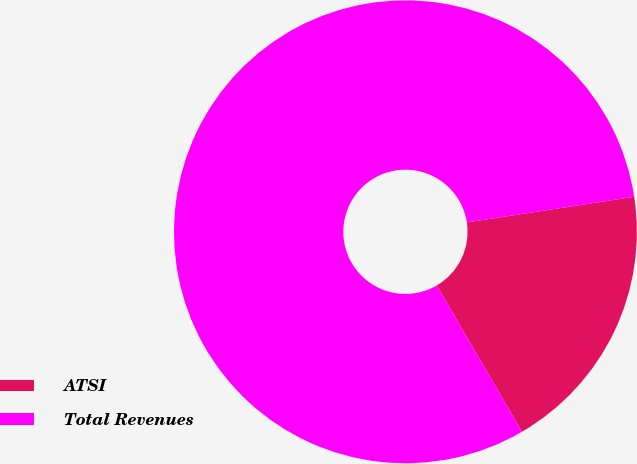Convert chart. <chart><loc_0><loc_0><loc_500><loc_500><pie_chart><fcel>ATSI<fcel>Total Revenues<nl><fcel>19.02%<fcel>80.98%<nl></chart> 